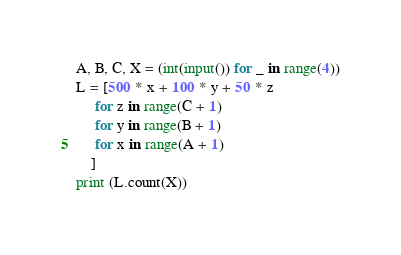Convert code to text. <code><loc_0><loc_0><loc_500><loc_500><_Python_>A, B, C, X = (int(input()) for _ in range(4))
L = [500 * x + 100 * y + 50 * z 
     for z in range(C + 1)
     for y in range(B + 1)
     for x in range(A + 1)
    ]
print (L.count(X))</code> 